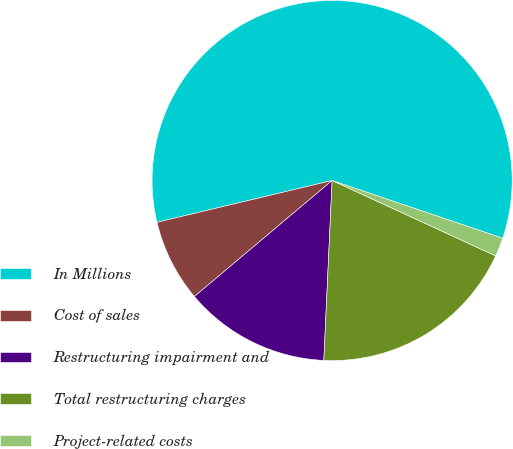Convert chart. <chart><loc_0><loc_0><loc_500><loc_500><pie_chart><fcel>In Millions<fcel>Cost of sales<fcel>Restructuring impairment and<fcel>Total restructuring charges<fcel>Project-related costs<nl><fcel>58.93%<fcel>7.41%<fcel>13.13%<fcel>18.86%<fcel>1.68%<nl></chart> 